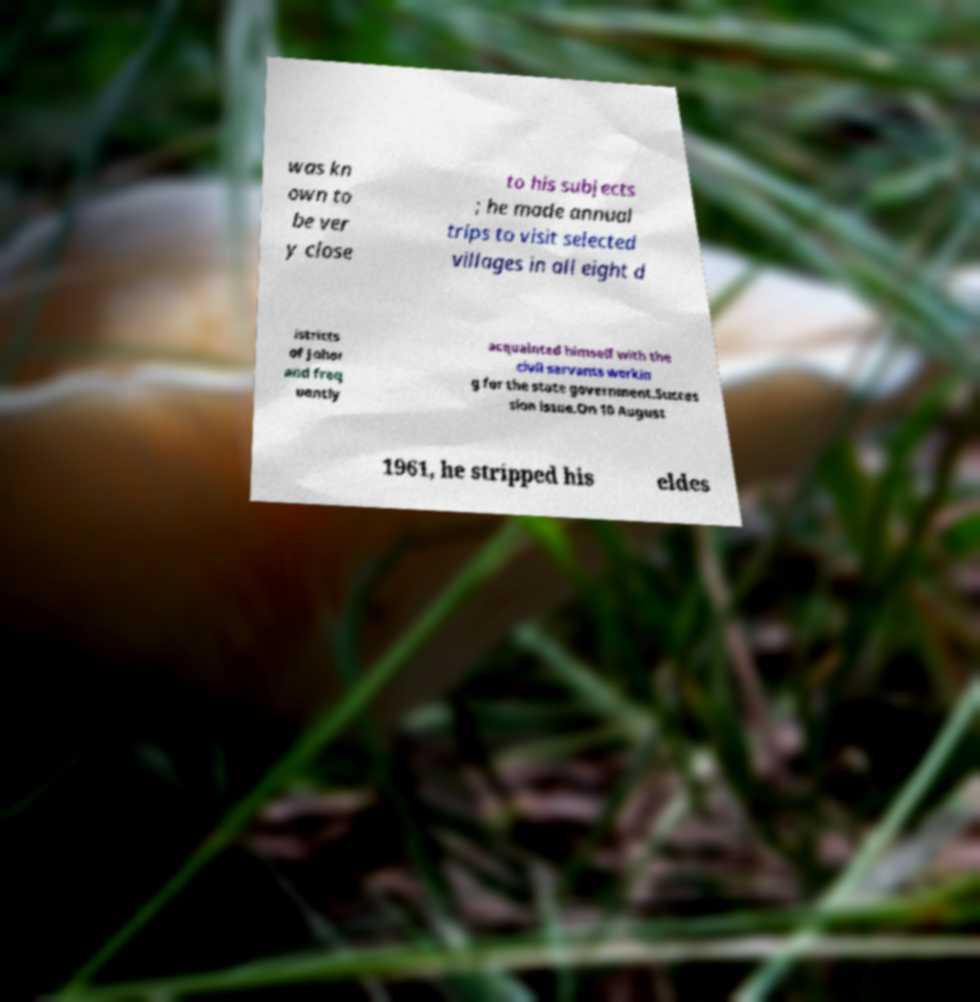For documentation purposes, I need the text within this image transcribed. Could you provide that? was kn own to be ver y close to his subjects ; he made annual trips to visit selected villages in all eight d istricts of Johor and freq uently acquainted himself with the civil servants workin g for the state government.Succes sion issue.On 10 August 1961, he stripped his eldes 